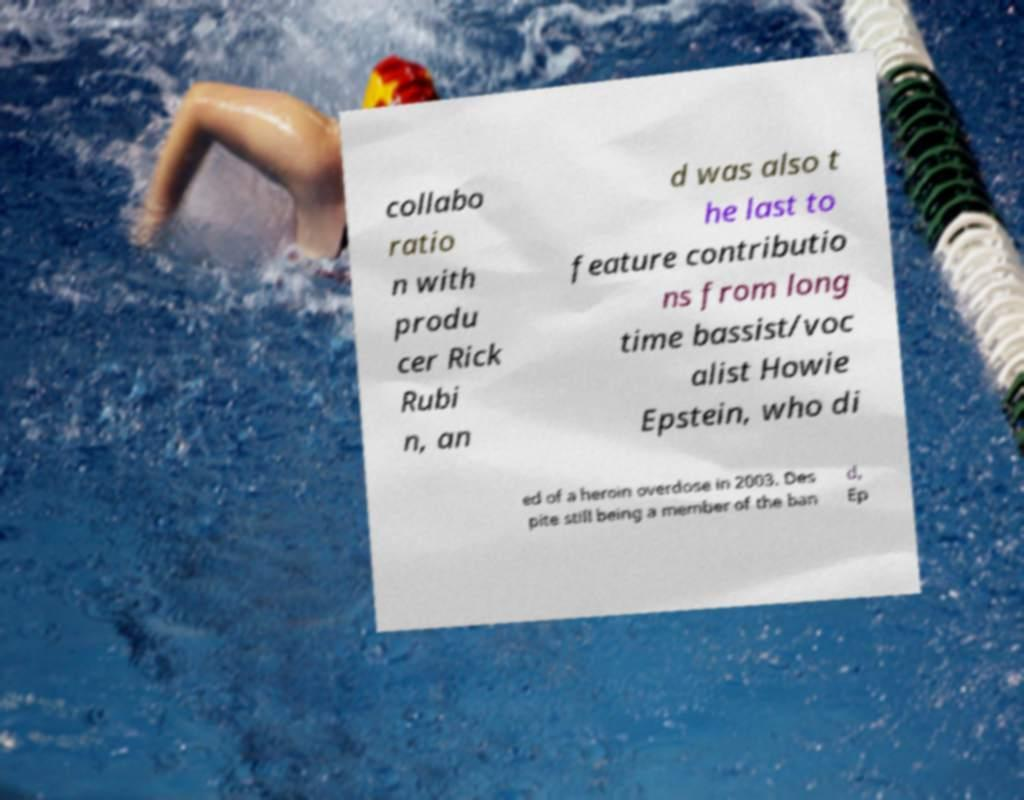Could you extract and type out the text from this image? collabo ratio n with produ cer Rick Rubi n, an d was also t he last to feature contributio ns from long time bassist/voc alist Howie Epstein, who di ed of a heroin overdose in 2003. Des pite still being a member of the ban d, Ep 